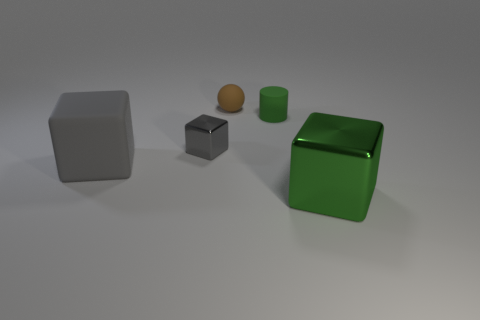Can you describe the lighting and shadows in the scene? Certainly! The image exhibits a soft, diffuse lighting, likely from an overhead source, leading to gentle shadows that lay mostly to the right of the objects. This lighting condition suggests an attempt to simulate a natural overcast sky or soft artificial light. 